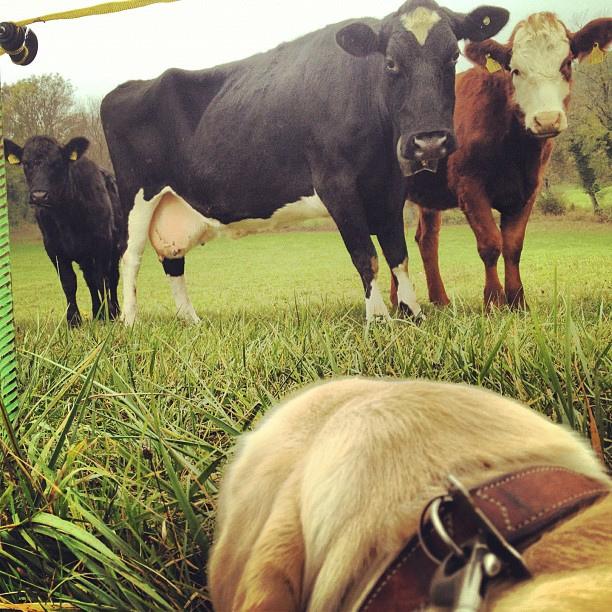Do the cows look curious?
Write a very short answer. Yes. How many species of animals are in the picture?
Short answer required. 2. What type of animal is laying in the foreground?
Answer briefly. Dog. Are the cows hornless?
Be succinct. Yes. 